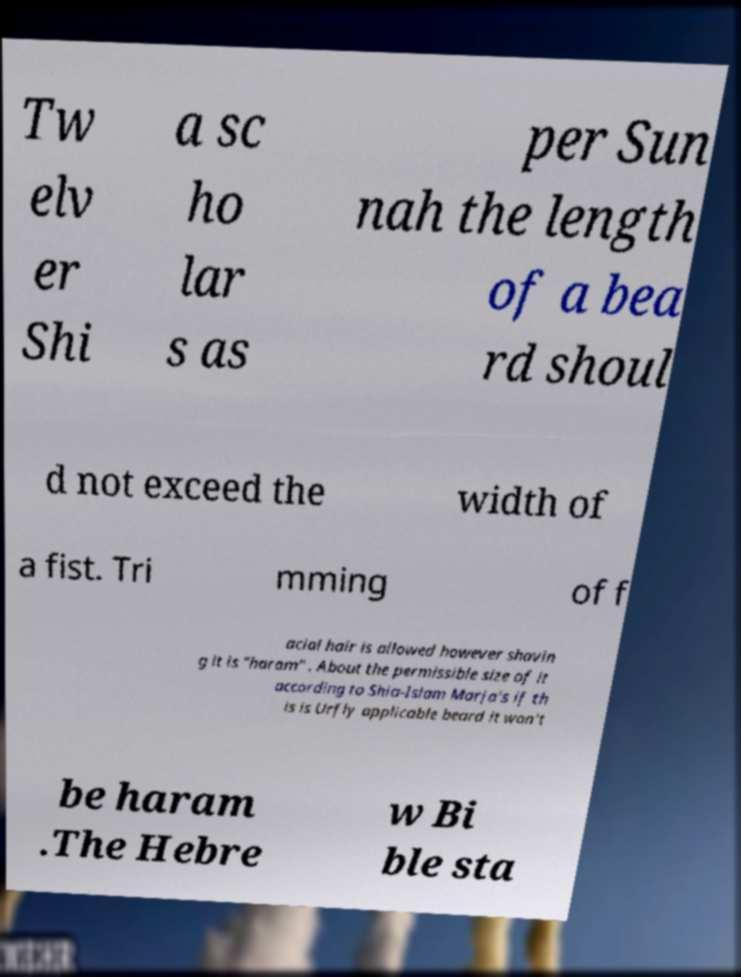Please identify and transcribe the text found in this image. Tw elv er Shi a sc ho lar s as per Sun nah the length of a bea rd shoul d not exceed the width of a fist. Tri mming of f acial hair is allowed however shavin g it is "haram" . About the permissible size of it according to Shia-Islam Marja's if th is is Urfly applicable beard it won't be haram .The Hebre w Bi ble sta 